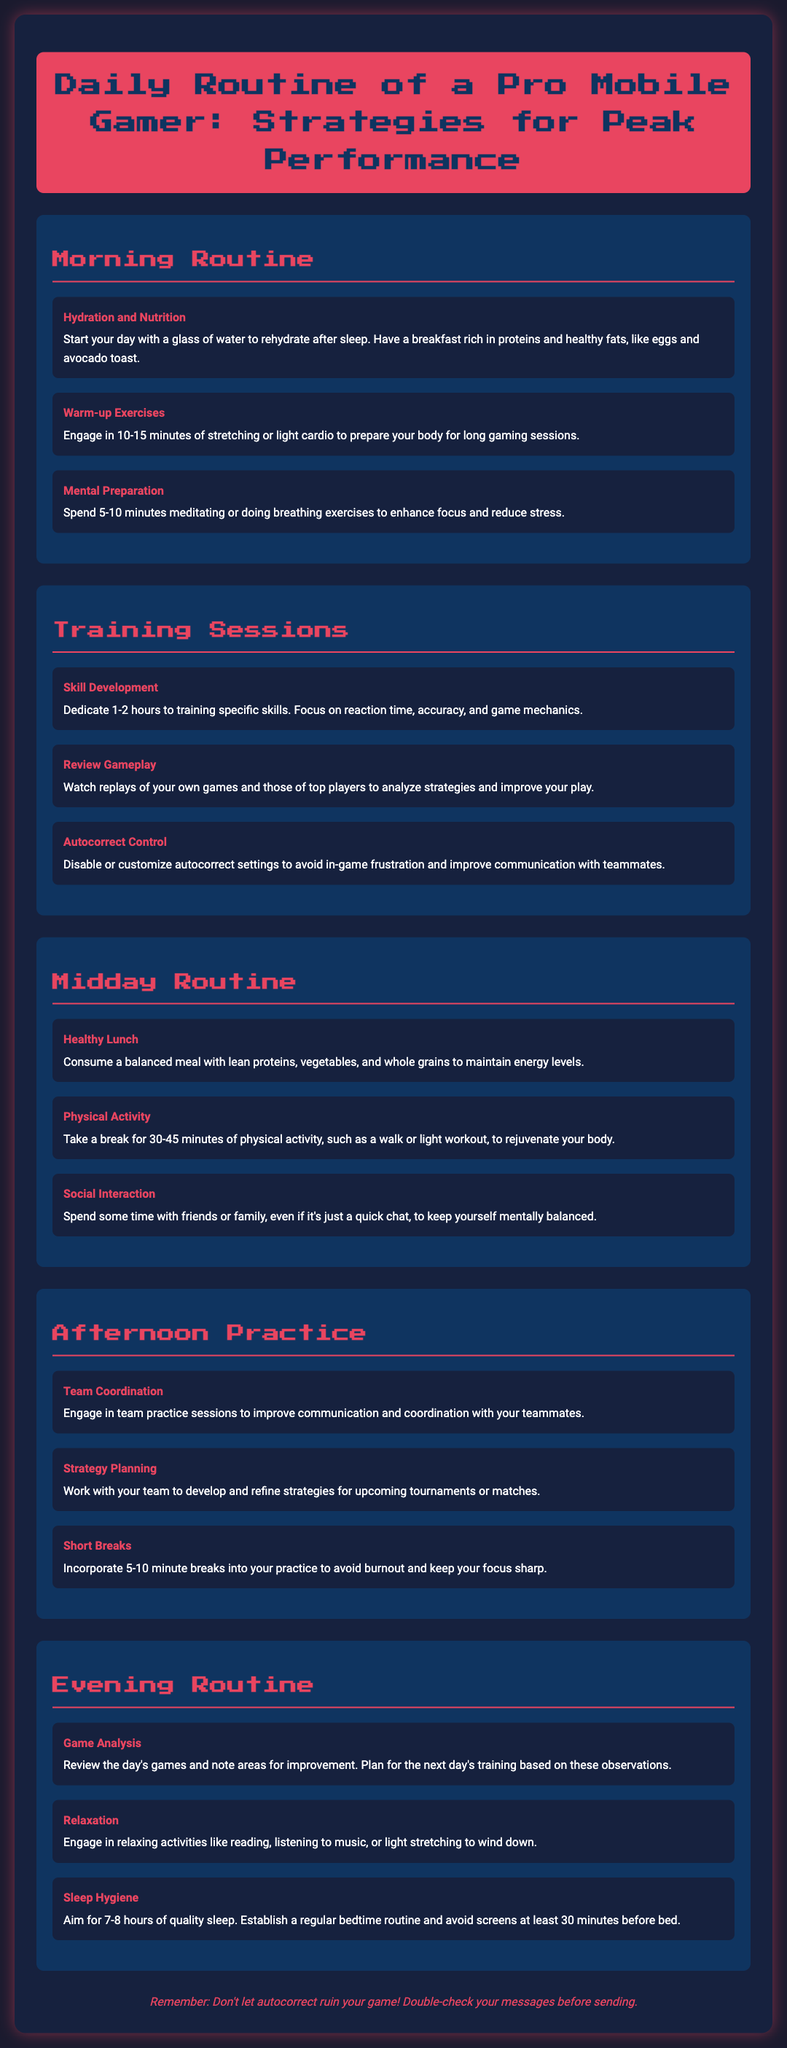what is the first item in the morning routine? The first item in the morning routine is "Hydration and Nutrition".
Answer: Hydration and Nutrition how long should warm-up exercises last? The document states that warm-up exercises should last 10-15 minutes.
Answer: 10-15 minutes how many hours should be dedicated to skill development? It mentions dedicating 1-2 hours to training specific skills.
Answer: 1-2 hours what is the main goal of midday routine activities? The midday routine activities aim to maintain energy levels and keep oneself mentally balanced.
Answer: Maintain energy levels what should gamers do during short breaks in afternoon practice? Gamers should incorporate 5-10 minute breaks into their practice to avoid burnout.
Answer: 5-10 minutes what should players focus on during team practice sessions? Players should focus on communication and coordination with teammates.
Answer: Communication and coordination how many hours of quality sleep should a gamer aim for? The document recommends aiming for 7-8 hours of quality sleep.
Answer: 7-8 hours what is a recommended activity to engage in during relaxation? The document suggests engaging in activities like reading or listening to music.
Answer: Reading or listening to music what warning is provided about autocorrect? The warning advises not to let autocorrect ruin your game and to double-check messages.
Answer: Double-check messages 